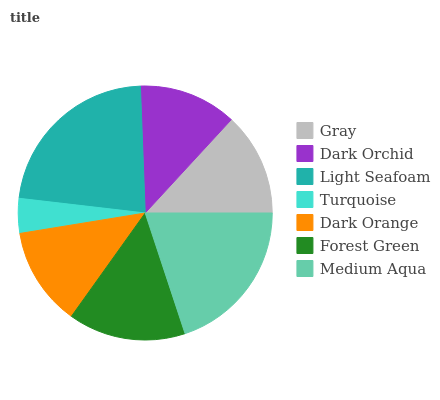Is Turquoise the minimum?
Answer yes or no. Yes. Is Light Seafoam the maximum?
Answer yes or no. Yes. Is Dark Orchid the minimum?
Answer yes or no. No. Is Dark Orchid the maximum?
Answer yes or no. No. Is Gray greater than Dark Orchid?
Answer yes or no. Yes. Is Dark Orchid less than Gray?
Answer yes or no. Yes. Is Dark Orchid greater than Gray?
Answer yes or no. No. Is Gray less than Dark Orchid?
Answer yes or no. No. Is Gray the high median?
Answer yes or no. Yes. Is Gray the low median?
Answer yes or no. Yes. Is Dark Orange the high median?
Answer yes or no. No. Is Medium Aqua the low median?
Answer yes or no. No. 